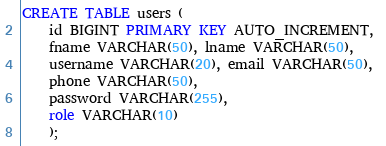<code> <loc_0><loc_0><loc_500><loc_500><_SQL_>CREATE TABLE users (
    id BIGINT PRIMARY KEY AUTO_INCREMENT, 
    fname VARCHAR(50), lname VARCHAR(50), 
    username VARCHAR(20), email VARCHAR(50), 
    phone VARCHAR(50), 
    password VARCHAR(255), 
    role VARCHAR(10)
    );</code> 